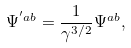Convert formula to latex. <formula><loc_0><loc_0><loc_500><loc_500>\Psi ^ { ^ { \prime } a b } = \frac { 1 } { \gamma ^ { 3 / 2 } } \Psi ^ { a b } ,</formula> 